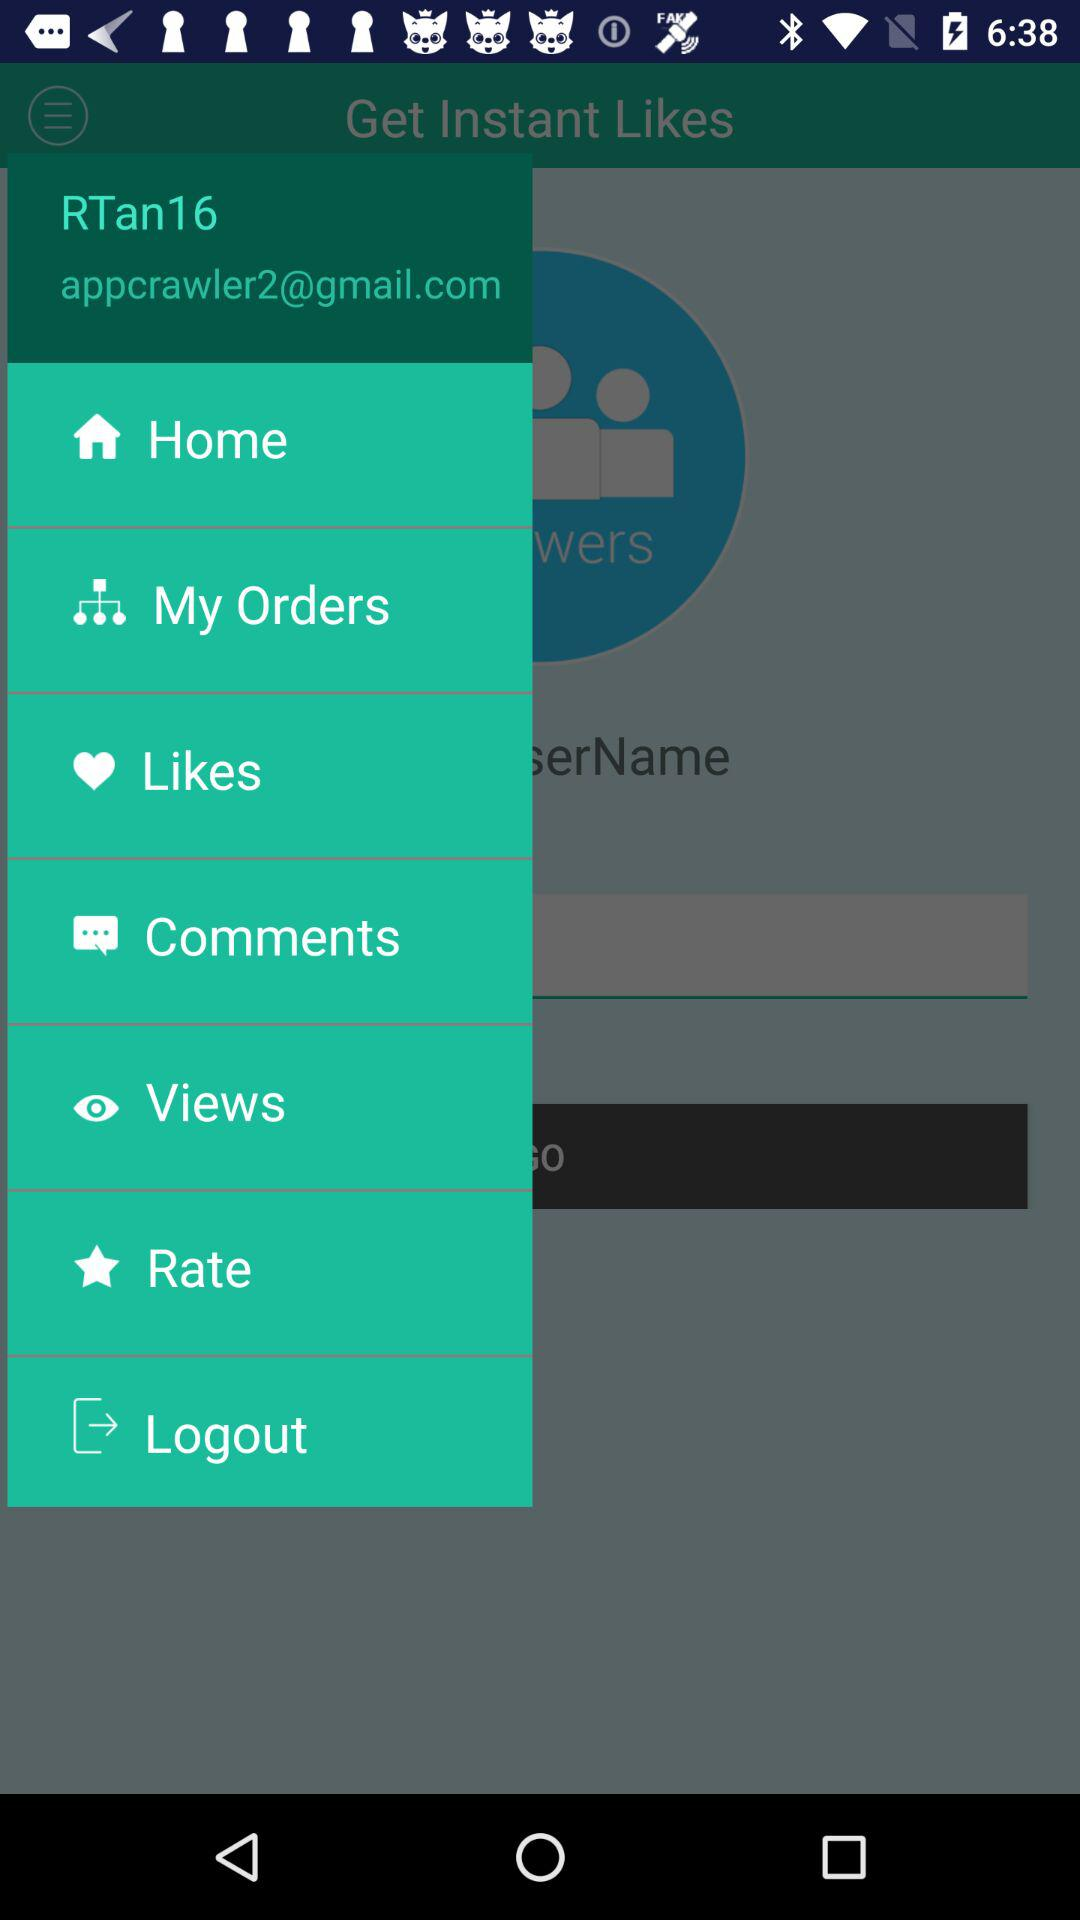What is the username? The username is "RTan16". 